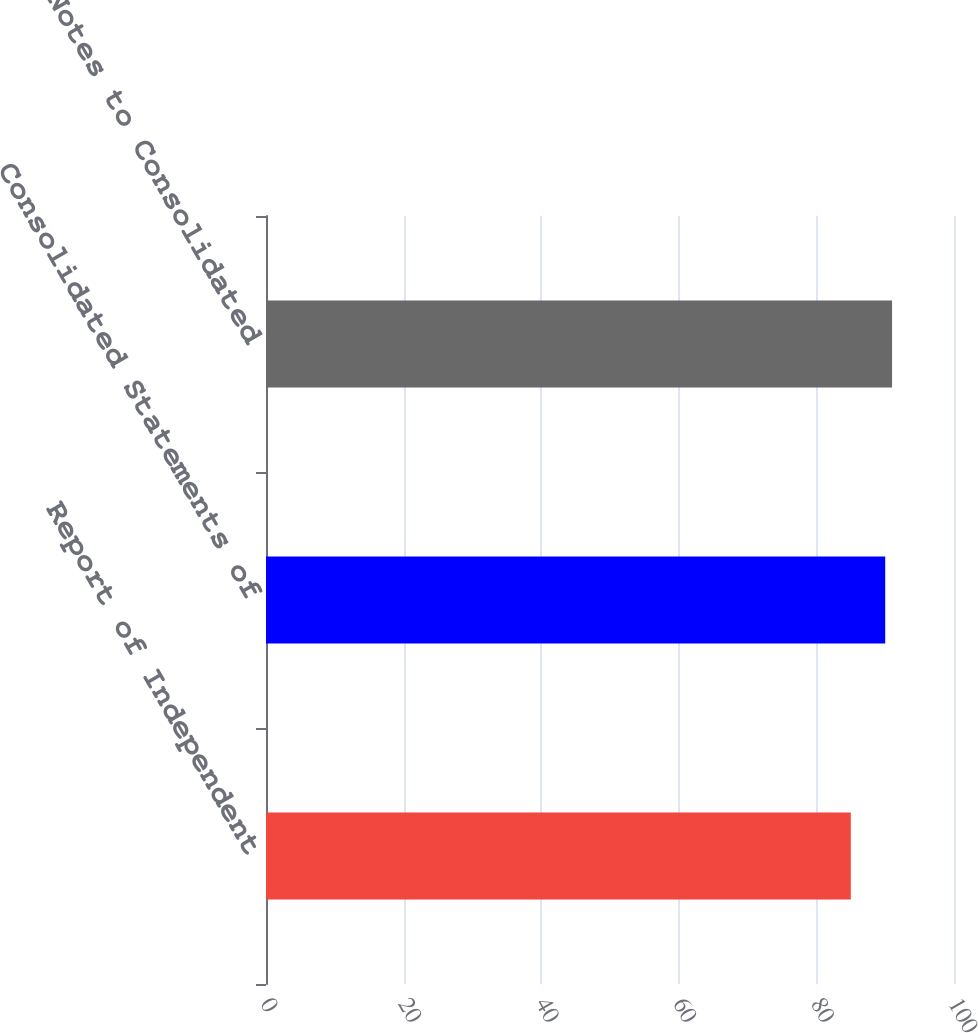Convert chart. <chart><loc_0><loc_0><loc_500><loc_500><bar_chart><fcel>Report of Independent<fcel>Consolidated Statements of<fcel>Notes to Consolidated<nl><fcel>85<fcel>90<fcel>91<nl></chart> 